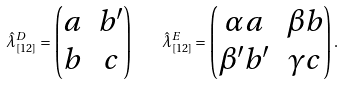Convert formula to latex. <formula><loc_0><loc_0><loc_500><loc_500>\hat { \lambda } ^ { D } _ { [ 1 2 ] } = \begin{pmatrix} a & b ^ { \prime } \\ b & c \end{pmatrix} \quad \hat { \lambda } ^ { E } _ { [ 1 2 ] } = \begin{pmatrix} \alpha a & \beta b \\ \beta ^ { \prime } b ^ { \prime } & \gamma c \end{pmatrix} .</formula> 